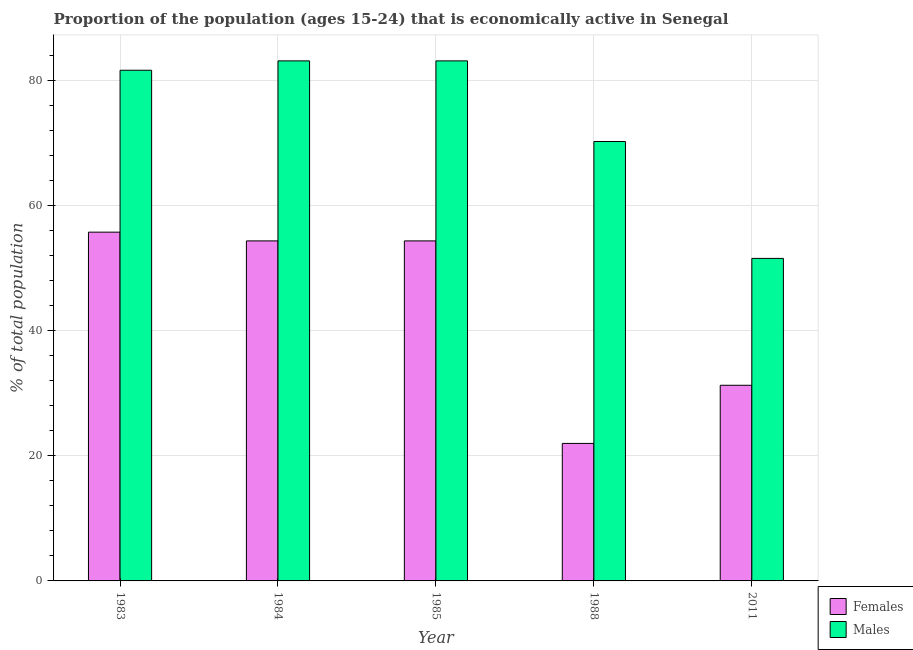How many different coloured bars are there?
Ensure brevity in your answer.  2. How many groups of bars are there?
Your answer should be very brief. 5. Are the number of bars on each tick of the X-axis equal?
Make the answer very short. Yes. How many bars are there on the 4th tick from the left?
Provide a short and direct response. 2. What is the label of the 5th group of bars from the left?
Give a very brief answer. 2011. What is the percentage of economically active male population in 1988?
Make the answer very short. 70.3. Across all years, what is the maximum percentage of economically active male population?
Offer a terse response. 83.2. In which year was the percentage of economically active male population maximum?
Your answer should be compact. 1984. What is the total percentage of economically active male population in the graph?
Offer a terse response. 370. What is the difference between the percentage of economically active female population in 1984 and that in 1988?
Your answer should be very brief. 32.4. What is the difference between the percentage of economically active female population in 2011 and the percentage of economically active male population in 1984?
Offer a very short reply. -23.1. What is the average percentage of economically active female population per year?
Provide a short and direct response. 43.58. In the year 1985, what is the difference between the percentage of economically active female population and percentage of economically active male population?
Provide a short and direct response. 0. What is the ratio of the percentage of economically active male population in 1985 to that in 1988?
Make the answer very short. 1.18. Is the percentage of economically active male population in 1984 less than that in 2011?
Provide a succinct answer. No. Is the difference between the percentage of economically active female population in 1983 and 2011 greater than the difference between the percentage of economically active male population in 1983 and 2011?
Offer a terse response. No. What is the difference between the highest and the second highest percentage of economically active female population?
Offer a terse response. 1.4. What is the difference between the highest and the lowest percentage of economically active male population?
Offer a terse response. 31.6. In how many years, is the percentage of economically active female population greater than the average percentage of economically active female population taken over all years?
Offer a very short reply. 3. What does the 2nd bar from the left in 1983 represents?
Offer a very short reply. Males. What does the 2nd bar from the right in 1985 represents?
Give a very brief answer. Females. Are all the bars in the graph horizontal?
Keep it short and to the point. No. How many years are there in the graph?
Keep it short and to the point. 5. What is the difference between two consecutive major ticks on the Y-axis?
Your response must be concise. 20. Does the graph contain grids?
Provide a short and direct response. Yes. Where does the legend appear in the graph?
Your answer should be very brief. Bottom right. What is the title of the graph?
Give a very brief answer. Proportion of the population (ages 15-24) that is economically active in Senegal. What is the label or title of the X-axis?
Offer a very short reply. Year. What is the label or title of the Y-axis?
Keep it short and to the point. % of total population. What is the % of total population in Females in 1983?
Your answer should be compact. 55.8. What is the % of total population in Males in 1983?
Your response must be concise. 81.7. What is the % of total population in Females in 1984?
Make the answer very short. 54.4. What is the % of total population in Males in 1984?
Offer a very short reply. 83.2. What is the % of total population of Females in 1985?
Offer a very short reply. 54.4. What is the % of total population of Males in 1985?
Provide a succinct answer. 83.2. What is the % of total population of Males in 1988?
Your answer should be compact. 70.3. What is the % of total population of Females in 2011?
Offer a terse response. 31.3. What is the % of total population in Males in 2011?
Keep it short and to the point. 51.6. Across all years, what is the maximum % of total population of Females?
Offer a terse response. 55.8. Across all years, what is the maximum % of total population of Males?
Offer a very short reply. 83.2. Across all years, what is the minimum % of total population in Females?
Your answer should be very brief. 22. Across all years, what is the minimum % of total population in Males?
Offer a terse response. 51.6. What is the total % of total population in Females in the graph?
Provide a short and direct response. 217.9. What is the total % of total population of Males in the graph?
Provide a short and direct response. 370. What is the difference between the % of total population of Females in 1983 and that in 1984?
Your answer should be compact. 1.4. What is the difference between the % of total population of Females in 1983 and that in 1988?
Your answer should be compact. 33.8. What is the difference between the % of total population in Females in 1983 and that in 2011?
Offer a terse response. 24.5. What is the difference between the % of total population in Males in 1983 and that in 2011?
Your response must be concise. 30.1. What is the difference between the % of total population of Females in 1984 and that in 1988?
Make the answer very short. 32.4. What is the difference between the % of total population in Females in 1984 and that in 2011?
Keep it short and to the point. 23.1. What is the difference between the % of total population in Males in 1984 and that in 2011?
Your response must be concise. 31.6. What is the difference between the % of total population in Females in 1985 and that in 1988?
Provide a short and direct response. 32.4. What is the difference between the % of total population of Males in 1985 and that in 1988?
Offer a terse response. 12.9. What is the difference between the % of total population in Females in 1985 and that in 2011?
Ensure brevity in your answer.  23.1. What is the difference between the % of total population of Males in 1985 and that in 2011?
Your answer should be compact. 31.6. What is the difference between the % of total population of Females in 1988 and that in 2011?
Give a very brief answer. -9.3. What is the difference between the % of total population in Males in 1988 and that in 2011?
Your answer should be very brief. 18.7. What is the difference between the % of total population in Females in 1983 and the % of total population in Males in 1984?
Make the answer very short. -27.4. What is the difference between the % of total population of Females in 1983 and the % of total population of Males in 1985?
Offer a terse response. -27.4. What is the difference between the % of total population in Females in 1983 and the % of total population in Males in 2011?
Ensure brevity in your answer.  4.2. What is the difference between the % of total population in Females in 1984 and the % of total population in Males in 1985?
Ensure brevity in your answer.  -28.8. What is the difference between the % of total population of Females in 1984 and the % of total population of Males in 1988?
Ensure brevity in your answer.  -15.9. What is the difference between the % of total population of Females in 1984 and the % of total population of Males in 2011?
Offer a very short reply. 2.8. What is the difference between the % of total population in Females in 1985 and the % of total population in Males in 1988?
Your response must be concise. -15.9. What is the difference between the % of total population of Females in 1985 and the % of total population of Males in 2011?
Your response must be concise. 2.8. What is the difference between the % of total population in Females in 1988 and the % of total population in Males in 2011?
Offer a terse response. -29.6. What is the average % of total population of Females per year?
Offer a terse response. 43.58. What is the average % of total population in Males per year?
Provide a short and direct response. 74. In the year 1983, what is the difference between the % of total population of Females and % of total population of Males?
Offer a terse response. -25.9. In the year 1984, what is the difference between the % of total population of Females and % of total population of Males?
Give a very brief answer. -28.8. In the year 1985, what is the difference between the % of total population of Females and % of total population of Males?
Your response must be concise. -28.8. In the year 1988, what is the difference between the % of total population in Females and % of total population in Males?
Ensure brevity in your answer.  -48.3. In the year 2011, what is the difference between the % of total population in Females and % of total population in Males?
Give a very brief answer. -20.3. What is the ratio of the % of total population of Females in 1983 to that in 1984?
Offer a very short reply. 1.03. What is the ratio of the % of total population in Females in 1983 to that in 1985?
Your answer should be compact. 1.03. What is the ratio of the % of total population of Males in 1983 to that in 1985?
Your answer should be very brief. 0.98. What is the ratio of the % of total population of Females in 1983 to that in 1988?
Provide a short and direct response. 2.54. What is the ratio of the % of total population in Males in 1983 to that in 1988?
Keep it short and to the point. 1.16. What is the ratio of the % of total population of Females in 1983 to that in 2011?
Give a very brief answer. 1.78. What is the ratio of the % of total population in Males in 1983 to that in 2011?
Offer a very short reply. 1.58. What is the ratio of the % of total population of Females in 1984 to that in 1988?
Your response must be concise. 2.47. What is the ratio of the % of total population of Males in 1984 to that in 1988?
Make the answer very short. 1.18. What is the ratio of the % of total population in Females in 1984 to that in 2011?
Your answer should be very brief. 1.74. What is the ratio of the % of total population in Males in 1984 to that in 2011?
Make the answer very short. 1.61. What is the ratio of the % of total population of Females in 1985 to that in 1988?
Your answer should be compact. 2.47. What is the ratio of the % of total population of Males in 1985 to that in 1988?
Provide a succinct answer. 1.18. What is the ratio of the % of total population of Females in 1985 to that in 2011?
Make the answer very short. 1.74. What is the ratio of the % of total population of Males in 1985 to that in 2011?
Your response must be concise. 1.61. What is the ratio of the % of total population in Females in 1988 to that in 2011?
Your response must be concise. 0.7. What is the ratio of the % of total population in Males in 1988 to that in 2011?
Your answer should be very brief. 1.36. What is the difference between the highest and the lowest % of total population of Females?
Your answer should be compact. 33.8. What is the difference between the highest and the lowest % of total population in Males?
Make the answer very short. 31.6. 